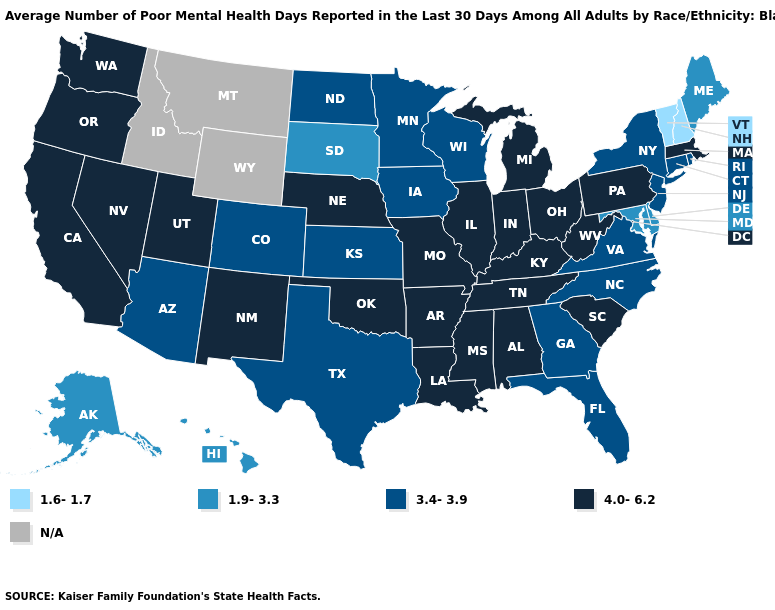Name the states that have a value in the range 1.9-3.3?
Concise answer only. Alaska, Delaware, Hawaii, Maine, Maryland, South Dakota. Among the states that border Delaware , which have the lowest value?
Quick response, please. Maryland. Name the states that have a value in the range 3.4-3.9?
Keep it brief. Arizona, Colorado, Connecticut, Florida, Georgia, Iowa, Kansas, Minnesota, New Jersey, New York, North Carolina, North Dakota, Rhode Island, Texas, Virginia, Wisconsin. Which states have the lowest value in the USA?
Keep it brief. New Hampshire, Vermont. How many symbols are there in the legend?
Write a very short answer. 5. Does Vermont have the lowest value in the USA?
Quick response, please. Yes. What is the lowest value in the USA?
Be succinct. 1.6-1.7. Among the states that border Montana , does South Dakota have the highest value?
Write a very short answer. No. Name the states that have a value in the range 1.6-1.7?
Keep it brief. New Hampshire, Vermont. Is the legend a continuous bar?
Be succinct. No. Which states hav the highest value in the MidWest?
Short answer required. Illinois, Indiana, Michigan, Missouri, Nebraska, Ohio. What is the value of Arkansas?
Answer briefly. 4.0-6.2. Name the states that have a value in the range 4.0-6.2?
Answer briefly. Alabama, Arkansas, California, Illinois, Indiana, Kentucky, Louisiana, Massachusetts, Michigan, Mississippi, Missouri, Nebraska, Nevada, New Mexico, Ohio, Oklahoma, Oregon, Pennsylvania, South Carolina, Tennessee, Utah, Washington, West Virginia. Which states have the lowest value in the South?
Write a very short answer. Delaware, Maryland. Name the states that have a value in the range 4.0-6.2?
Answer briefly. Alabama, Arkansas, California, Illinois, Indiana, Kentucky, Louisiana, Massachusetts, Michigan, Mississippi, Missouri, Nebraska, Nevada, New Mexico, Ohio, Oklahoma, Oregon, Pennsylvania, South Carolina, Tennessee, Utah, Washington, West Virginia. 